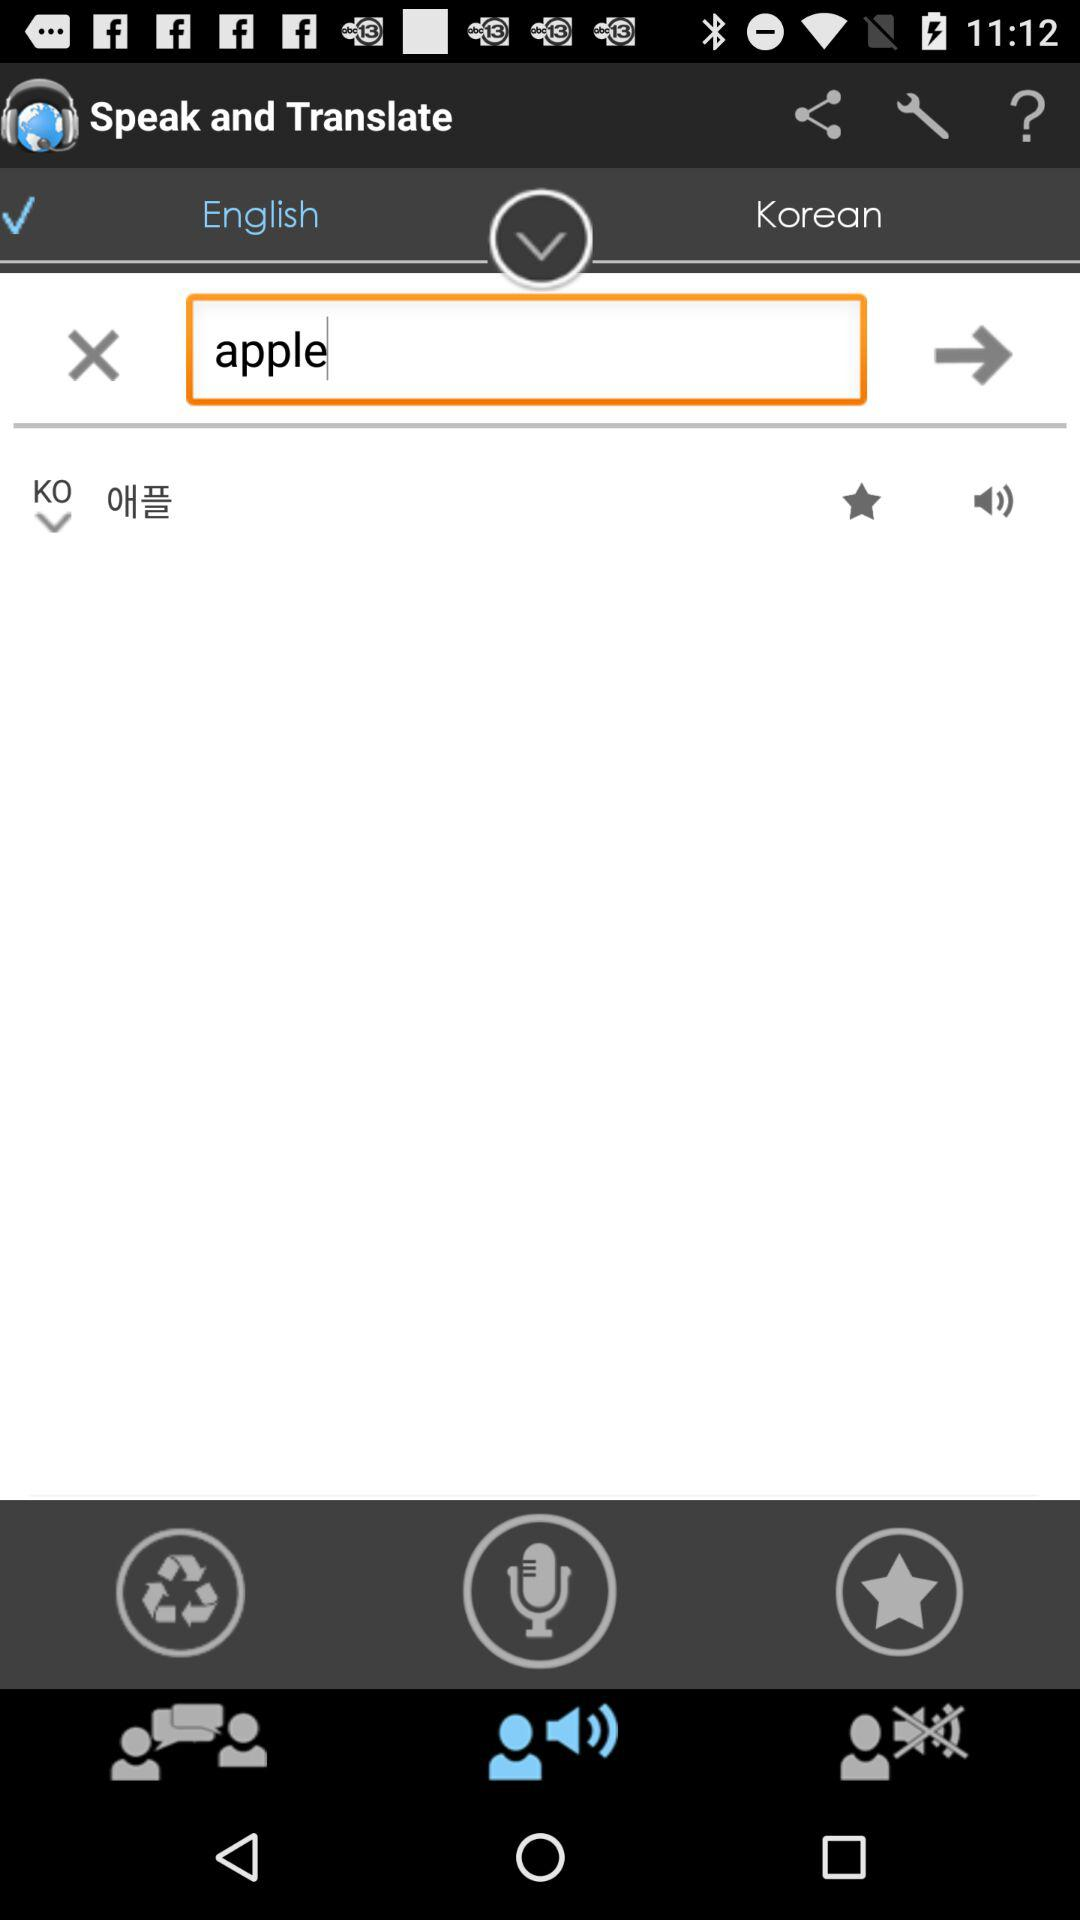In which language does the person want the translation? The person wants the translation in Korean. 